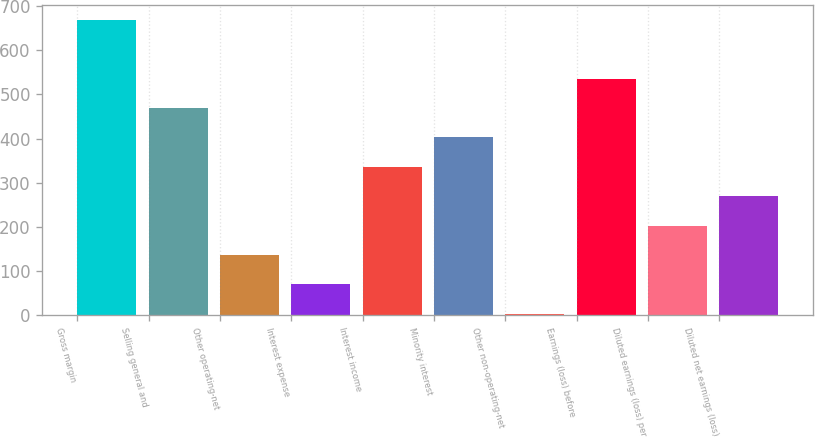<chart> <loc_0><loc_0><loc_500><loc_500><bar_chart><fcel>Gross margin<fcel>Selling general and<fcel>Other operating-net<fcel>Interest expense<fcel>Interest income<fcel>Minority interest<fcel>Other non-operating-net<fcel>Earnings (loss) before<fcel>Diluted earnings (loss) per<fcel>Diluted net earnings (loss)<nl><fcel>670<fcel>469.48<fcel>135.28<fcel>68.44<fcel>335.8<fcel>402.64<fcel>1.6<fcel>536.32<fcel>202.12<fcel>268.96<nl></chart> 